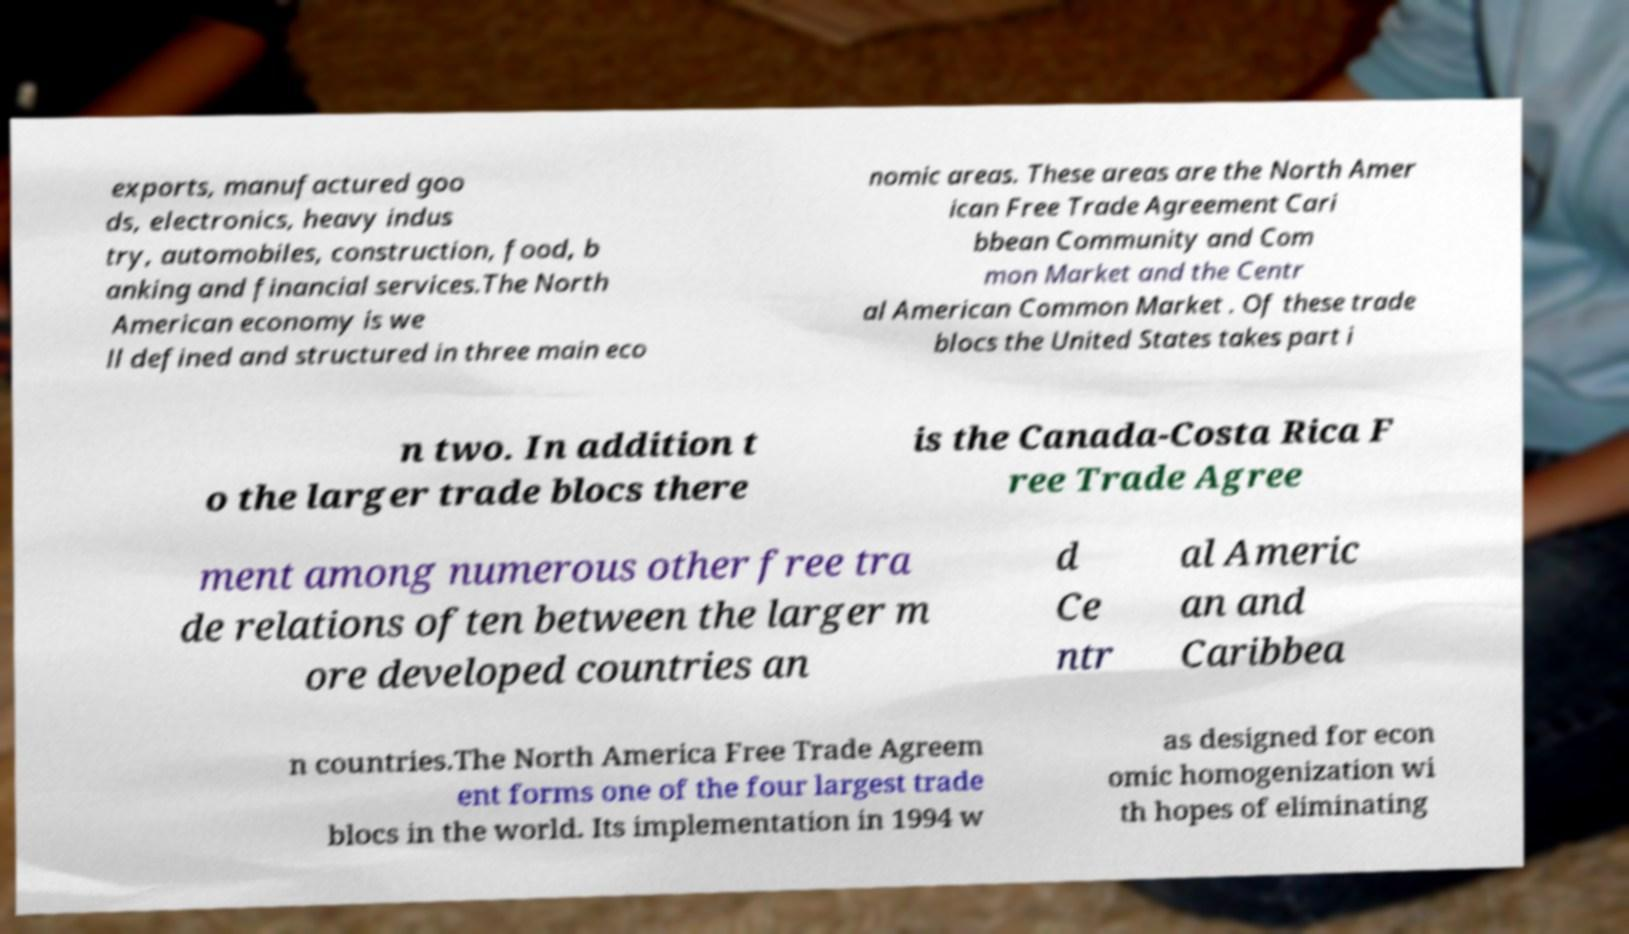For documentation purposes, I need the text within this image transcribed. Could you provide that? exports, manufactured goo ds, electronics, heavy indus try, automobiles, construction, food, b anking and financial services.The North American economy is we ll defined and structured in three main eco nomic areas. These areas are the North Amer ican Free Trade Agreement Cari bbean Community and Com mon Market and the Centr al American Common Market . Of these trade blocs the United States takes part i n two. In addition t o the larger trade blocs there is the Canada-Costa Rica F ree Trade Agree ment among numerous other free tra de relations often between the larger m ore developed countries an d Ce ntr al Americ an and Caribbea n countries.The North America Free Trade Agreem ent forms one of the four largest trade blocs in the world. Its implementation in 1994 w as designed for econ omic homogenization wi th hopes of eliminating 